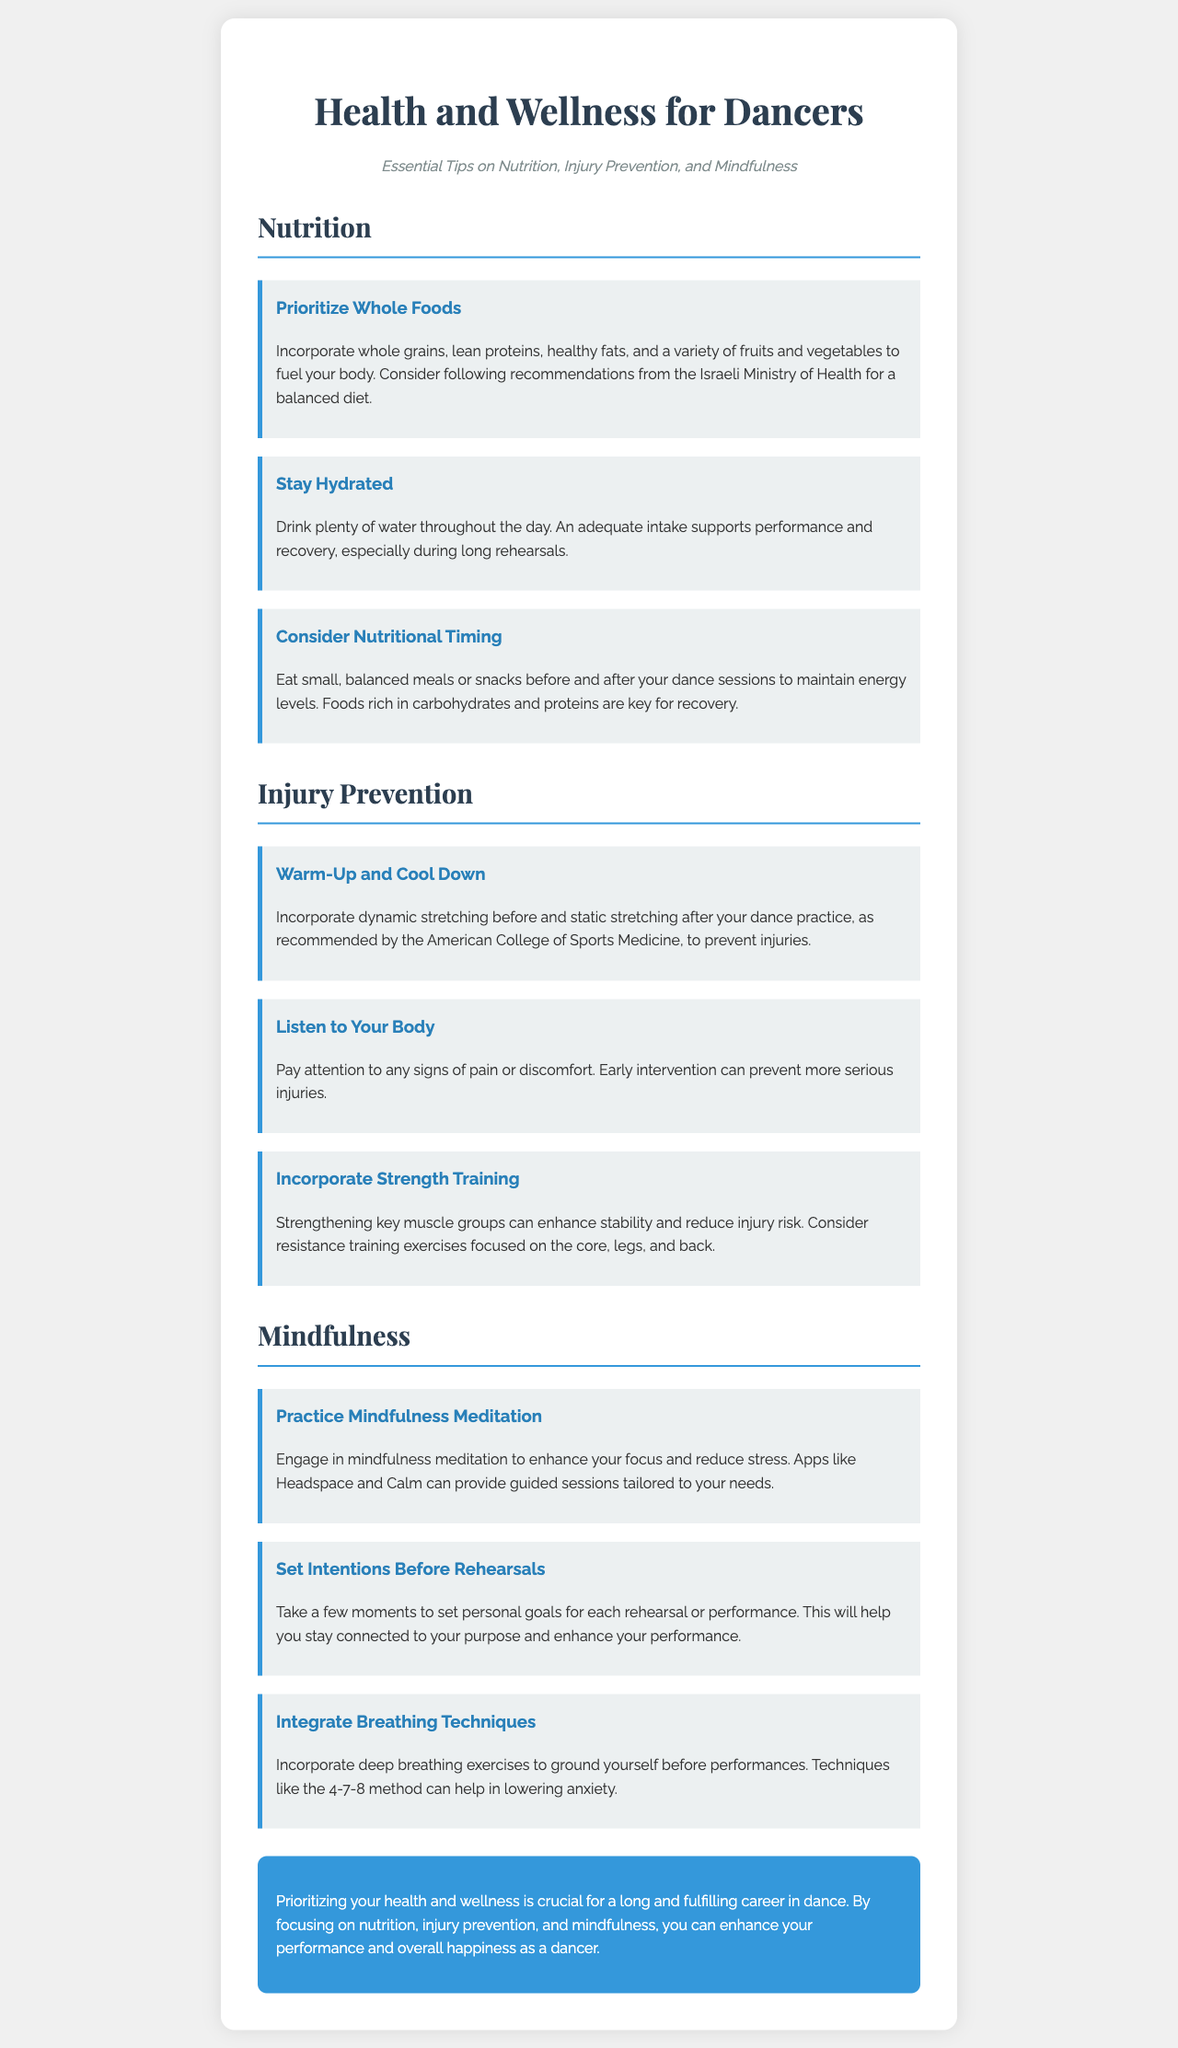What are the three main sections of the newsletter? The newsletter is divided into three main sections: Nutrition, Injury Prevention, and Mindfulness.
Answer: Nutrition, Injury Prevention, Mindfulness What is one recommendation for hydration? The document states that an adequate intake supports performance and recovery, especially during long rehearsals.
Answer: Drink plenty of water Which method is suggested for breath control before performances? The 4-7-8 method is mentioned for lowering anxiety and grounding oneself before performances.
Answer: 4-7-8 method How many tips are provided under the Nutrition section? The document lists three specific tips under the Nutrition section.
Answer: Three What does the document recommend doing before and after dance practice? Dynamic stretching is recommended before, and static stretching after dance practice to prevent injuries.
Answer: Dynamic stretching before; static stretching after What is advised in terms of setting personal goals? The document suggests setting intentions for each rehearsal or performance to stay connected to the dancer's purpose.
Answer: Set personal goals How does the newsletter suggest preventing injuries? It emphasizes listening to your body and paying attention to signs of pain or discomfort for early intervention.
Answer: Listen to your body What color is used for the conclusion section background? The conclusion section has a background color of #3498db.
Answer: #3498db 